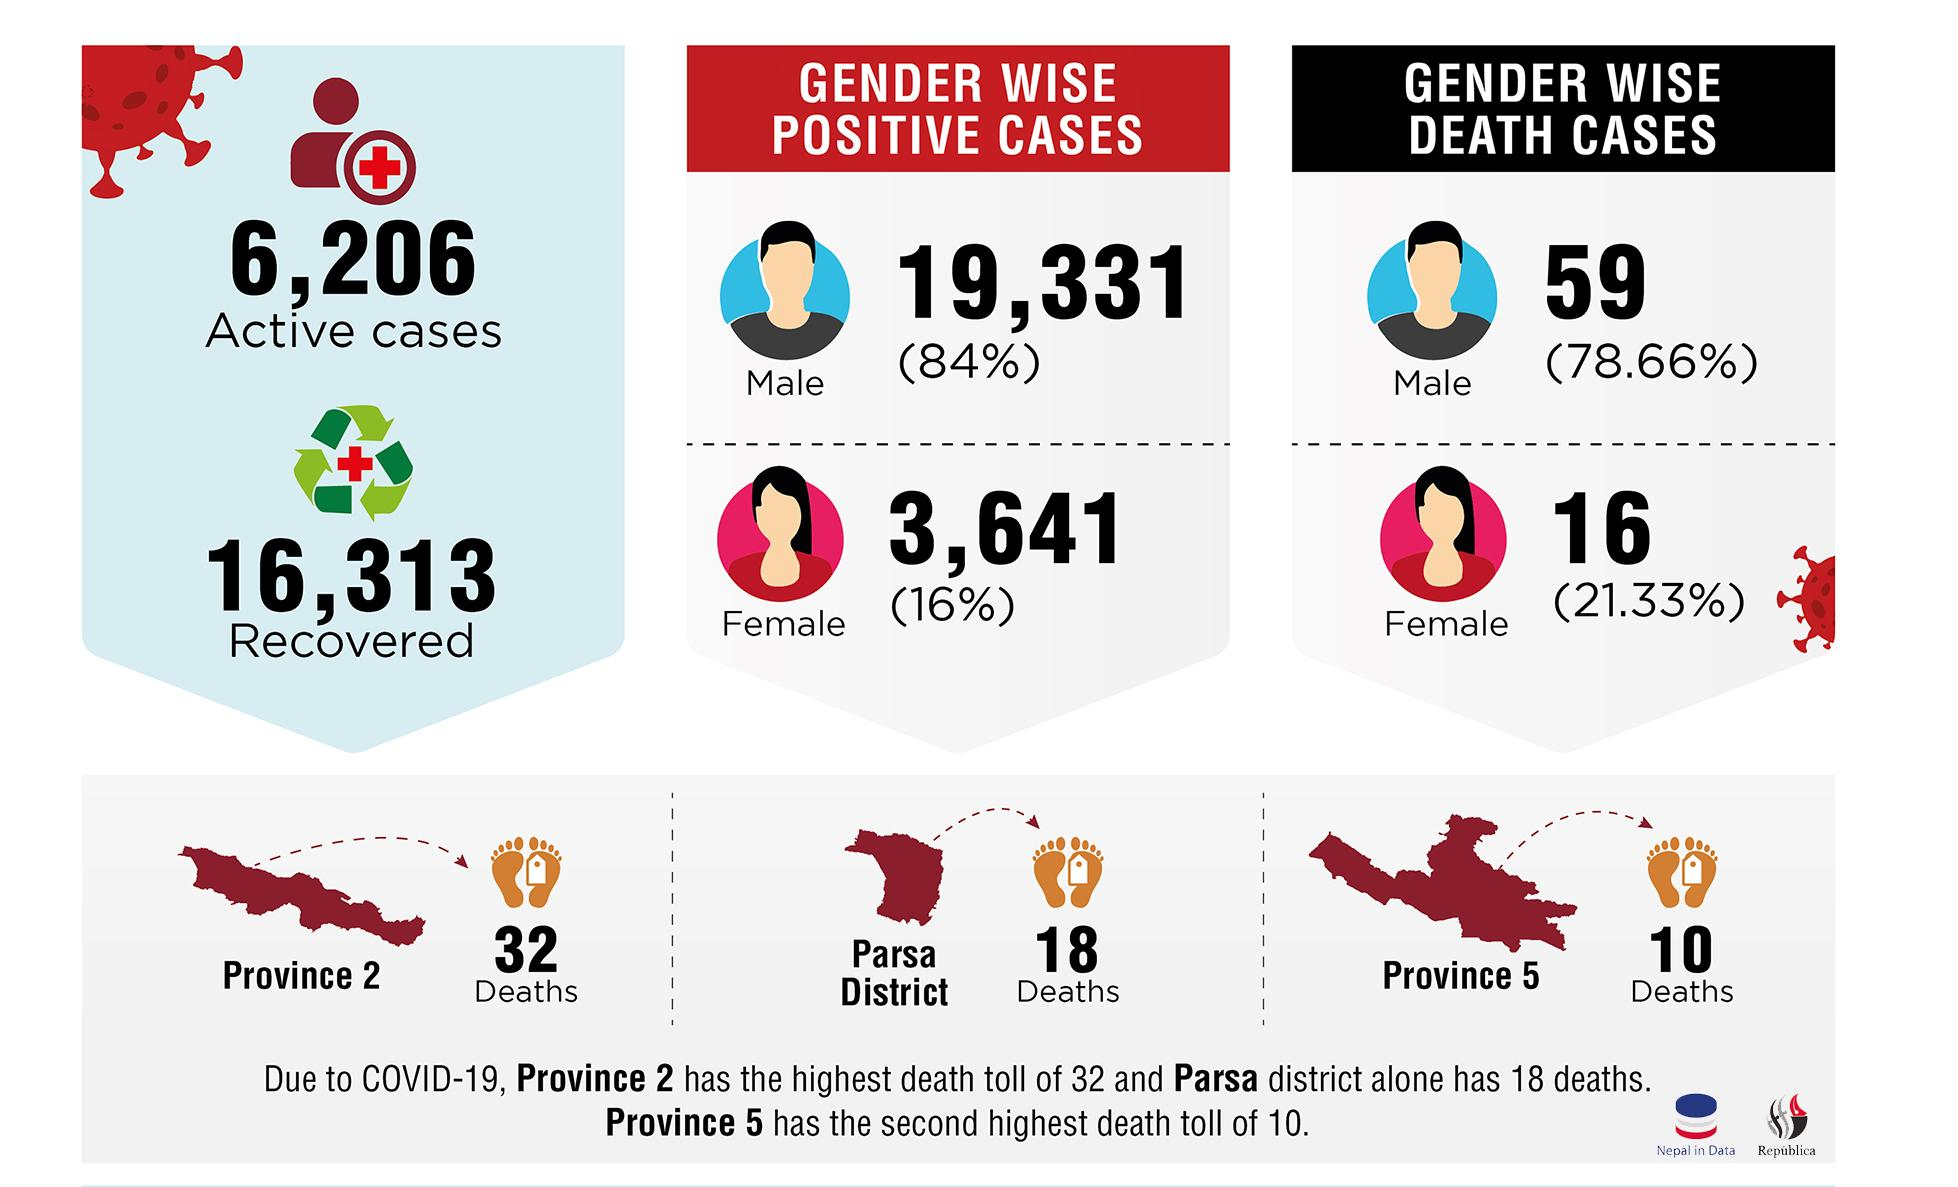Indicate a few pertinent items in this graphic. The gender with the highest number of positive cases is male. Province 2 had 22 more deaths than Province 5. The percentage of positive cases among females is lower than among males, at 68%. The death cases are higher in males by 57.33% compared to females. 